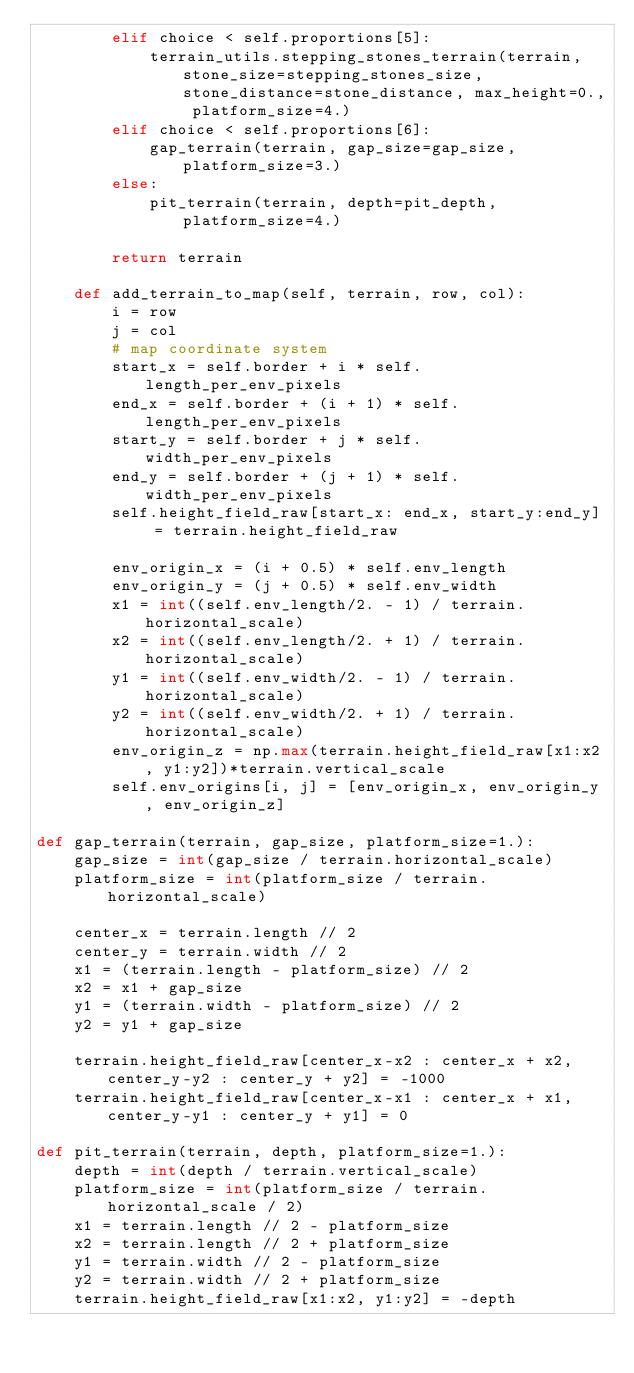Convert code to text. <code><loc_0><loc_0><loc_500><loc_500><_Python_>        elif choice < self.proportions[5]:
            terrain_utils.stepping_stones_terrain(terrain, stone_size=stepping_stones_size, stone_distance=stone_distance, max_height=0., platform_size=4.)
        elif choice < self.proportions[6]:
            gap_terrain(terrain, gap_size=gap_size, platform_size=3.)
        else:
            pit_terrain(terrain, depth=pit_depth, platform_size=4.)
        
        return terrain

    def add_terrain_to_map(self, terrain, row, col):
        i = row
        j = col
        # map coordinate system
        start_x = self.border + i * self.length_per_env_pixels
        end_x = self.border + (i + 1) * self.length_per_env_pixels
        start_y = self.border + j * self.width_per_env_pixels
        end_y = self.border + (j + 1) * self.width_per_env_pixels
        self.height_field_raw[start_x: end_x, start_y:end_y] = terrain.height_field_raw

        env_origin_x = (i + 0.5) * self.env_length
        env_origin_y = (j + 0.5) * self.env_width
        x1 = int((self.env_length/2. - 1) / terrain.horizontal_scale)
        x2 = int((self.env_length/2. + 1) / terrain.horizontal_scale)
        y1 = int((self.env_width/2. - 1) / terrain.horizontal_scale)
        y2 = int((self.env_width/2. + 1) / terrain.horizontal_scale)
        env_origin_z = np.max(terrain.height_field_raw[x1:x2, y1:y2])*terrain.vertical_scale
        self.env_origins[i, j] = [env_origin_x, env_origin_y, env_origin_z]

def gap_terrain(terrain, gap_size, platform_size=1.):
    gap_size = int(gap_size / terrain.horizontal_scale)
    platform_size = int(platform_size / terrain.horizontal_scale)

    center_x = terrain.length // 2
    center_y = terrain.width // 2
    x1 = (terrain.length - platform_size) // 2
    x2 = x1 + gap_size
    y1 = (terrain.width - platform_size) // 2
    y2 = y1 + gap_size
   
    terrain.height_field_raw[center_x-x2 : center_x + x2, center_y-y2 : center_y + y2] = -1000
    terrain.height_field_raw[center_x-x1 : center_x + x1, center_y-y1 : center_y + y1] = 0

def pit_terrain(terrain, depth, platform_size=1.):
    depth = int(depth / terrain.vertical_scale)
    platform_size = int(platform_size / terrain.horizontal_scale / 2)
    x1 = terrain.length // 2 - platform_size
    x2 = terrain.length // 2 + platform_size
    y1 = terrain.width // 2 - platform_size
    y2 = terrain.width // 2 + platform_size
    terrain.height_field_raw[x1:x2, y1:y2] = -depth
</code> 